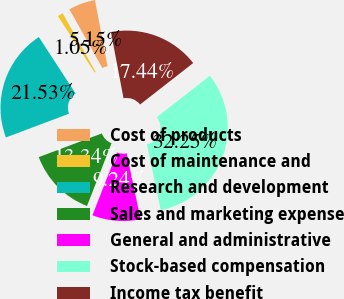Convert chart to OTSL. <chart><loc_0><loc_0><loc_500><loc_500><pie_chart><fcel>Cost of products<fcel>Cost of maintenance and<fcel>Research and development<fcel>Sales and marketing expense<fcel>General and administrative<fcel>Stock-based compensation<fcel>Income tax benefit<nl><fcel>5.15%<fcel>1.05%<fcel>21.53%<fcel>13.34%<fcel>9.24%<fcel>32.25%<fcel>17.44%<nl></chart> 